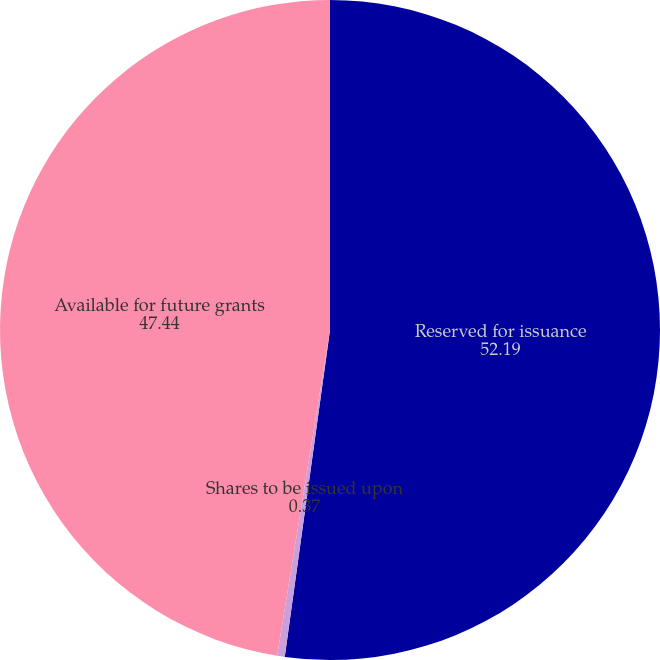<chart> <loc_0><loc_0><loc_500><loc_500><pie_chart><fcel>Reserved for issuance<fcel>Shares to be issued upon<fcel>Available for future grants<nl><fcel>52.19%<fcel>0.37%<fcel>47.44%<nl></chart> 